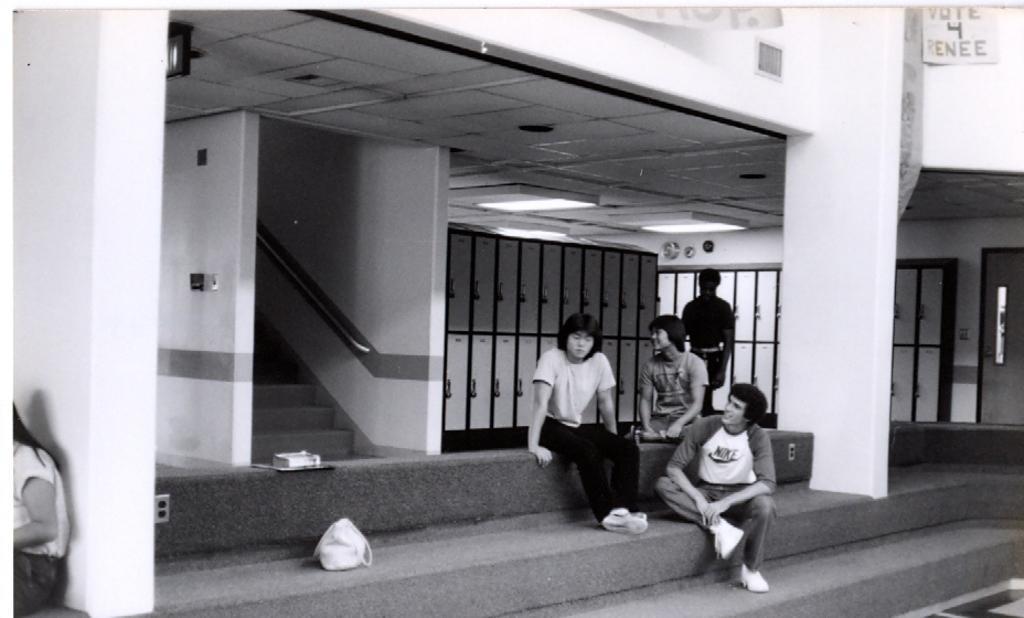Please provide a concise description of this image. In this image I can see few people where one is standing and rest all are sitting. I can also see stairs, a bag, few lights and number of lockers in the background. 